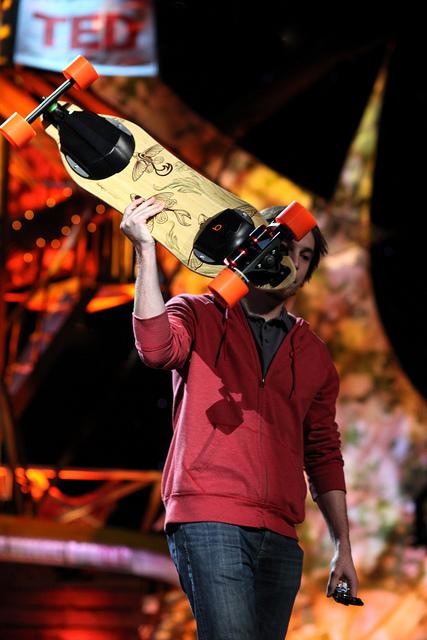What is he carrying?
Keep it brief. Skateboard. What is the man holding in  his left hand?
Answer briefly. Skateboard. What color is his jacket?
Keep it brief. Red. 